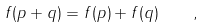<formula> <loc_0><loc_0><loc_500><loc_500>f ( p + q ) = f ( p ) + f ( q ) \quad ,</formula> 